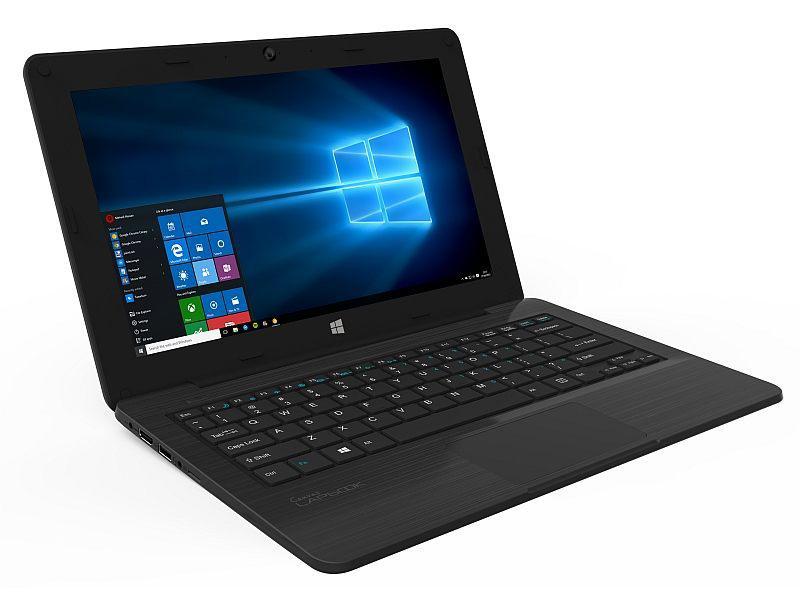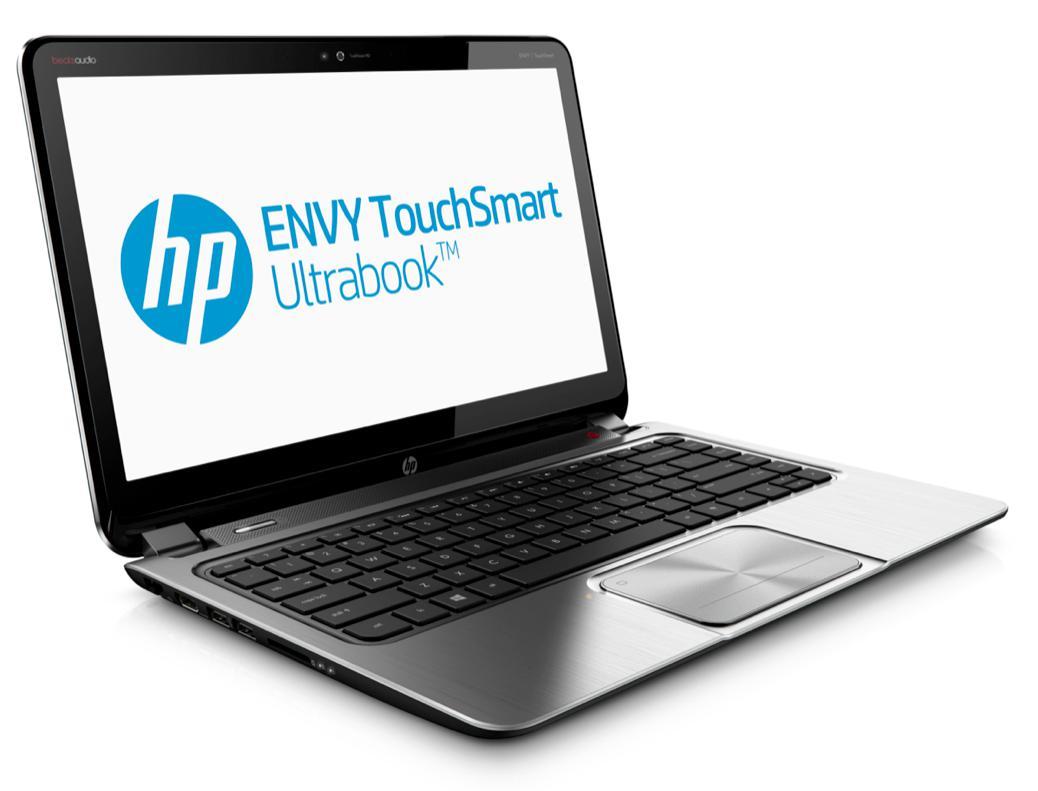The first image is the image on the left, the second image is the image on the right. Assess this claim about the two images: "there is a laptop with a screen showing a windows logo with light shining through the window". Correct or not? Answer yes or no. Yes. The first image is the image on the left, the second image is the image on the right. For the images shown, is this caption "All laptops are angled with the open screen facing rightward, and one laptop features a blue screen with a white circle logo on it." true? Answer yes or no. No. 